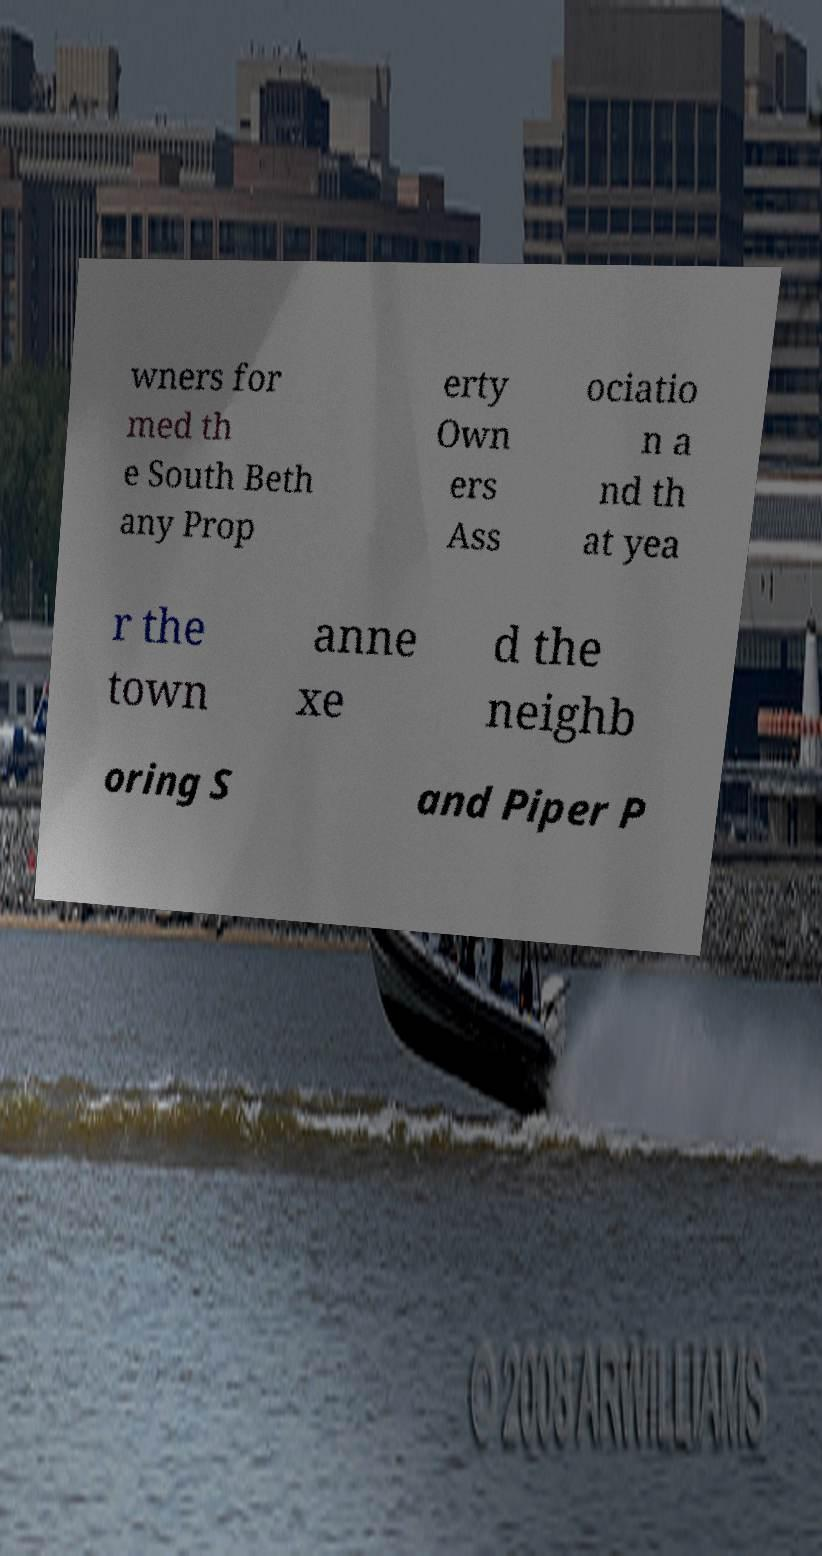Please read and relay the text visible in this image. What does it say? wners for med th e South Beth any Prop erty Own ers Ass ociatio n a nd th at yea r the town anne xe d the neighb oring S and Piper P 